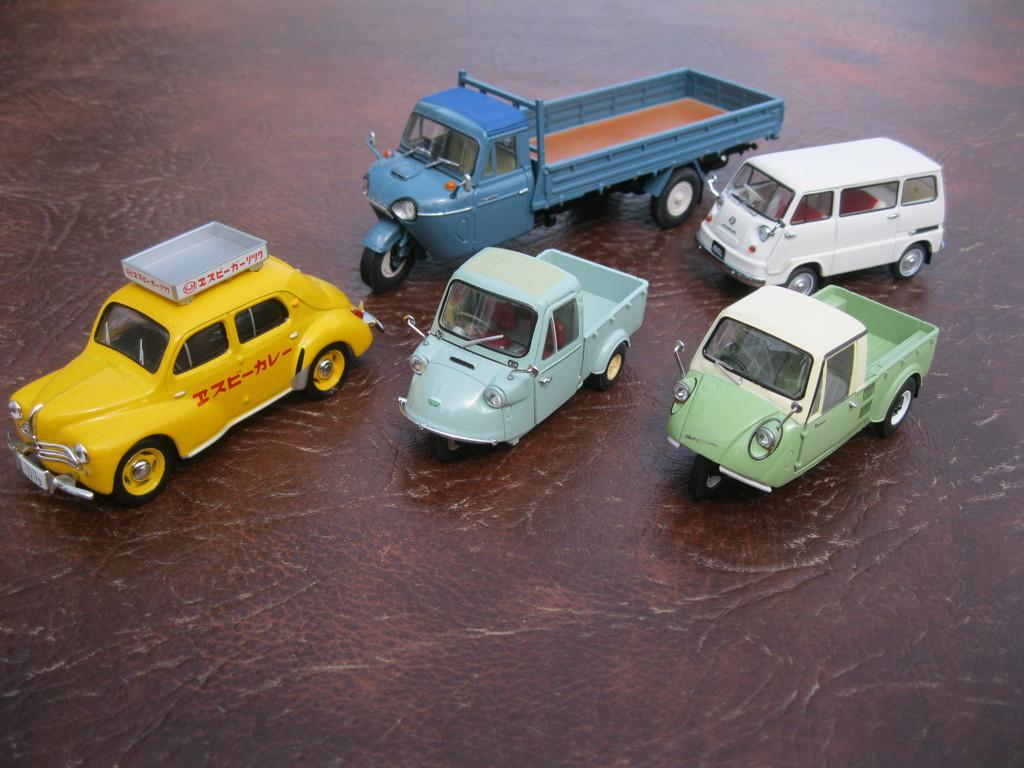Provide a one-sentence caption for the provided image. Five trucks sitting on a table with a yellow truck that has foreign letters looking to be HNC on the side. 